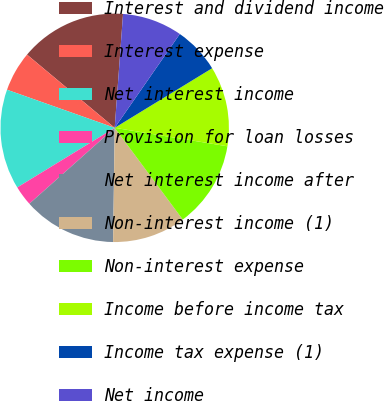Convert chart to OTSL. <chart><loc_0><loc_0><loc_500><loc_500><pie_chart><fcel>Interest and dividend income<fcel>Interest expense<fcel>Net interest income<fcel>Provision for loan losses<fcel>Net interest income after<fcel>Non-interest income (1)<fcel>Non-interest expense<fcel>Income before income tax<fcel>Income tax expense (1)<fcel>Net income<nl><fcel>15.09%<fcel>5.66%<fcel>14.15%<fcel>2.83%<fcel>13.21%<fcel>10.38%<fcel>12.26%<fcel>11.32%<fcel>6.61%<fcel>8.49%<nl></chart> 